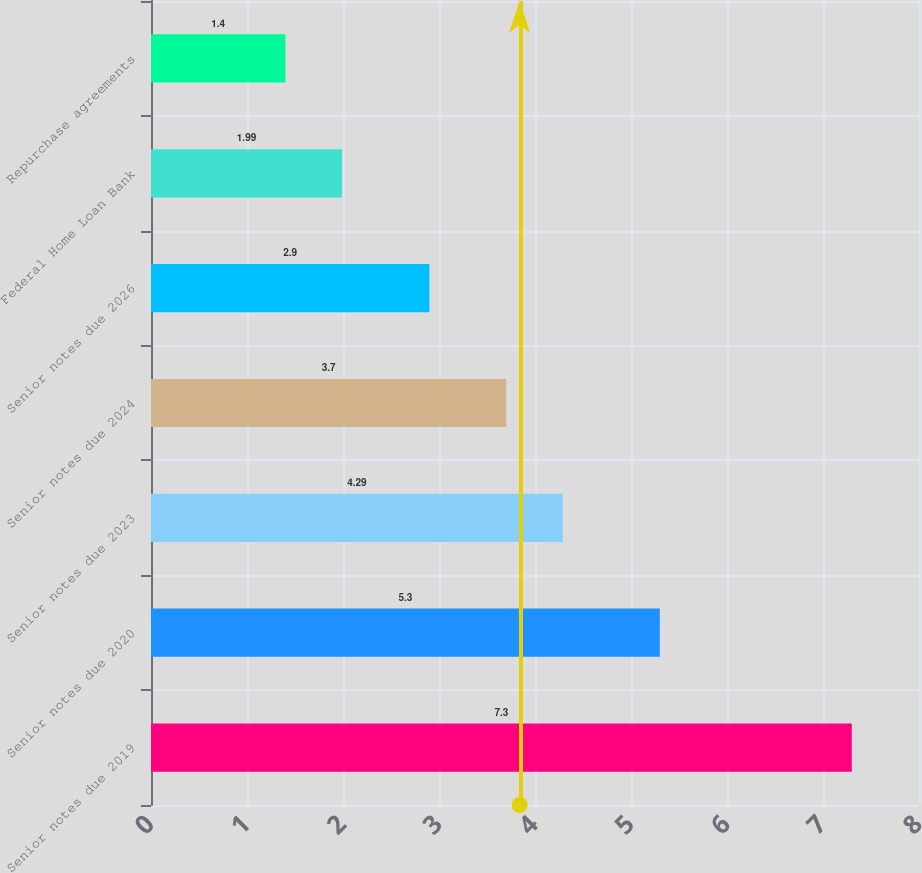Convert chart. <chart><loc_0><loc_0><loc_500><loc_500><bar_chart><fcel>Senior notes due 2019<fcel>Senior notes due 2020<fcel>Senior notes due 2023<fcel>Senior notes due 2024<fcel>Senior notes due 2026<fcel>Federal Home Loan Bank<fcel>Repurchase agreements<nl><fcel>7.3<fcel>5.3<fcel>4.29<fcel>3.7<fcel>2.9<fcel>1.99<fcel>1.4<nl></chart> 